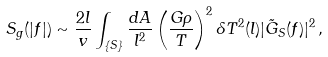Convert formula to latex. <formula><loc_0><loc_0><loc_500><loc_500>S _ { g } ( | f | ) \sim \frac { 2 l } { v } \int _ { \{ S \} } \frac { d A } { l ^ { 2 } } \left ( \frac { G \rho } { T } \right ) ^ { 2 } \delta T ^ { 2 } ( l ) | \tilde { G } _ { S } ( f ) | ^ { 2 } \, ,</formula> 